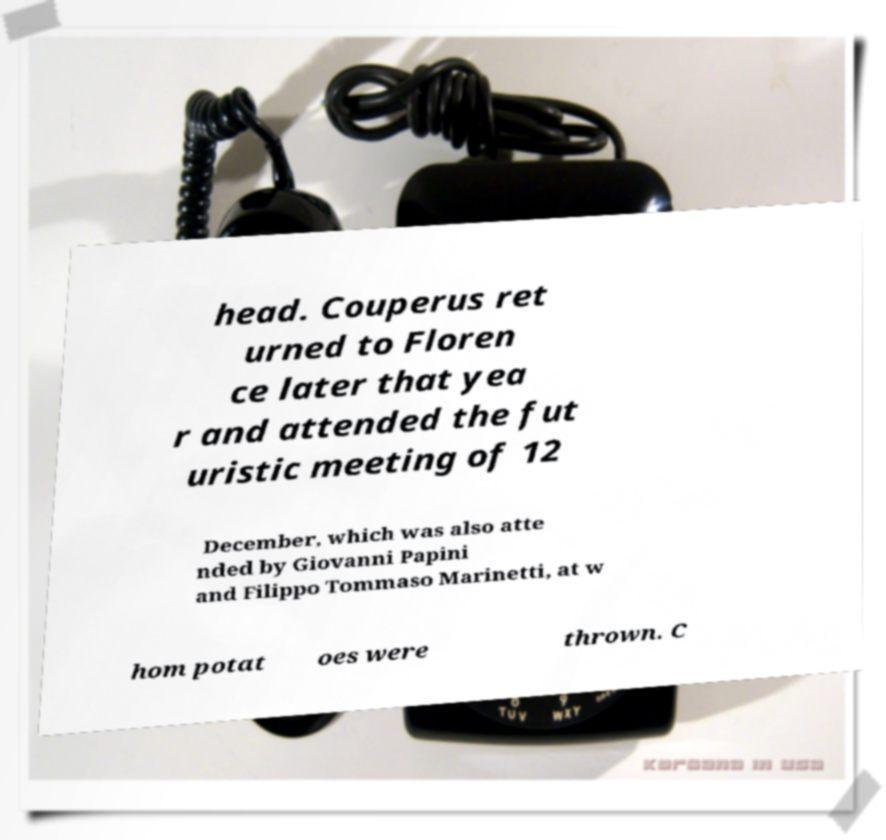Could you extract and type out the text from this image? head. Couperus ret urned to Floren ce later that yea r and attended the fut uristic meeting of 12 December, which was also atte nded by Giovanni Papini and Filippo Tommaso Marinetti, at w hom potat oes were thrown. C 